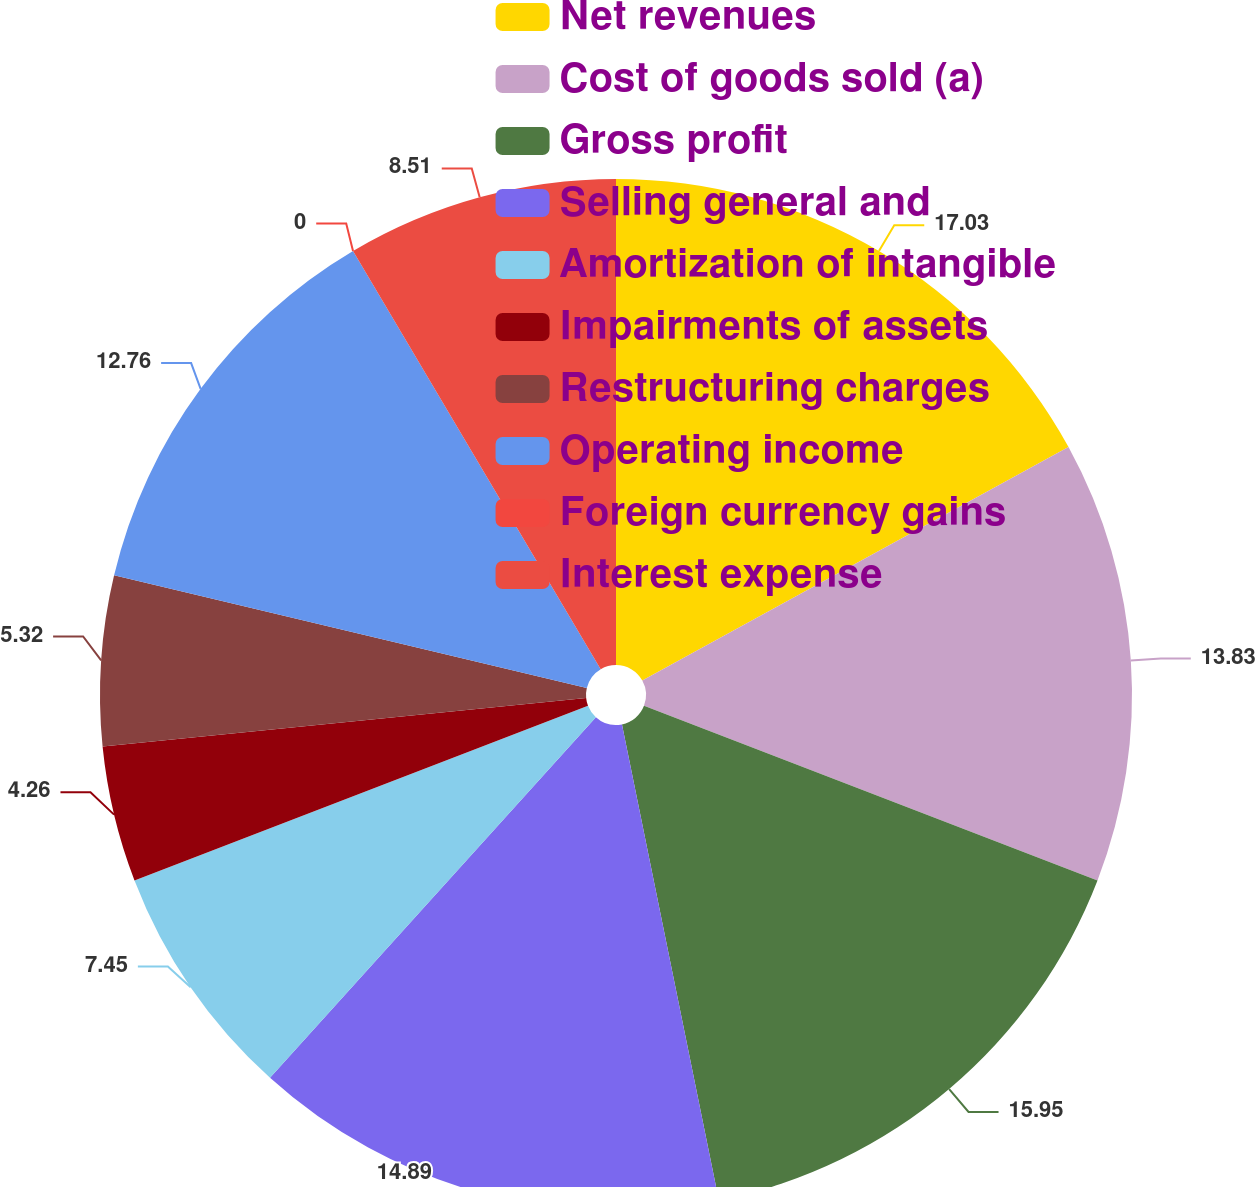Convert chart to OTSL. <chart><loc_0><loc_0><loc_500><loc_500><pie_chart><fcel>Net revenues<fcel>Cost of goods sold (a)<fcel>Gross profit<fcel>Selling general and<fcel>Amortization of intangible<fcel>Impairments of assets<fcel>Restructuring charges<fcel>Operating income<fcel>Foreign currency gains<fcel>Interest expense<nl><fcel>17.02%<fcel>13.83%<fcel>15.95%<fcel>14.89%<fcel>7.45%<fcel>4.26%<fcel>5.32%<fcel>12.76%<fcel>0.0%<fcel>8.51%<nl></chart> 